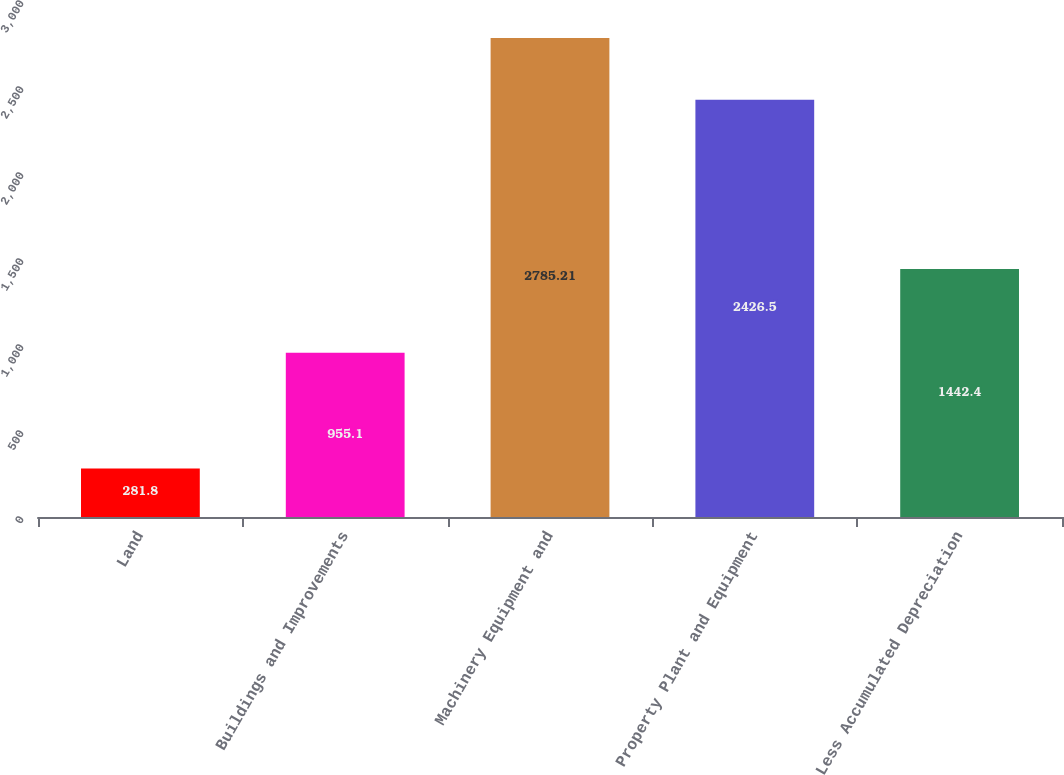Convert chart. <chart><loc_0><loc_0><loc_500><loc_500><bar_chart><fcel>Land<fcel>Buildings and Improvements<fcel>Machinery Equipment and<fcel>Property Plant and Equipment<fcel>Less Accumulated Depreciation<nl><fcel>281.8<fcel>955.1<fcel>2785.21<fcel>2426.5<fcel>1442.4<nl></chart> 